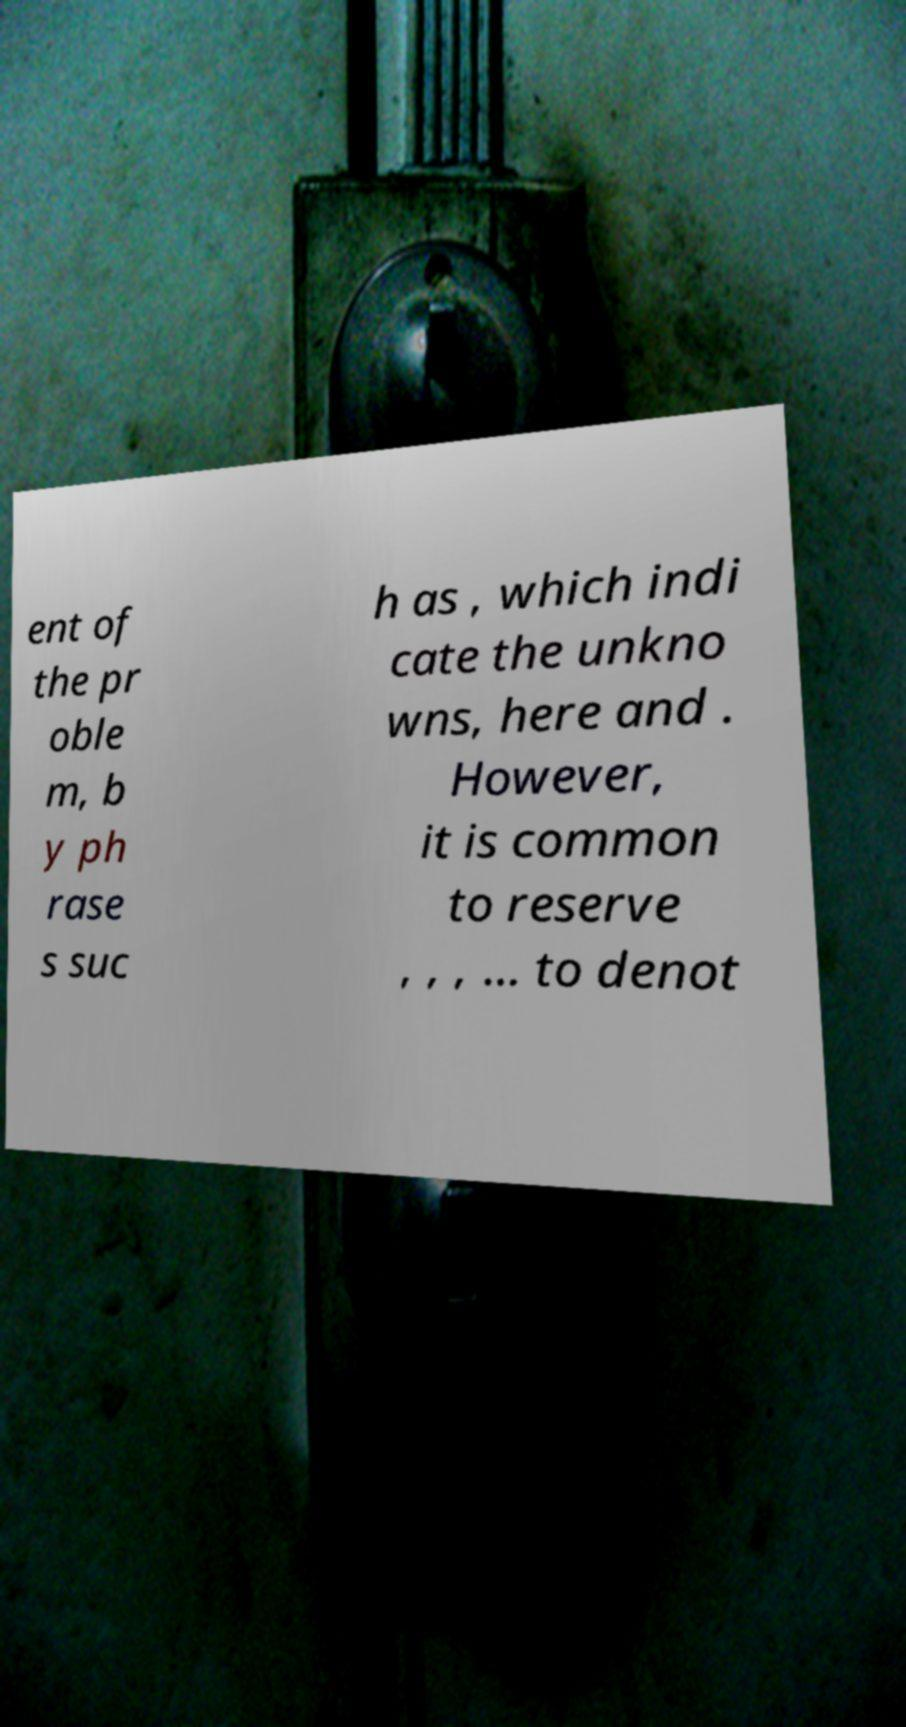What messages or text are displayed in this image? I need them in a readable, typed format. ent of the pr oble m, b y ph rase s suc h as , which indi cate the unkno wns, here and . However, it is common to reserve , , , ... to denot 